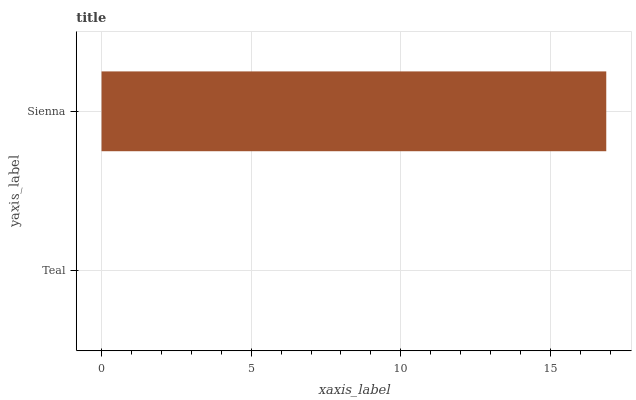Is Teal the minimum?
Answer yes or no. Yes. Is Sienna the maximum?
Answer yes or no. Yes. Is Sienna the minimum?
Answer yes or no. No. Is Sienna greater than Teal?
Answer yes or no. Yes. Is Teal less than Sienna?
Answer yes or no. Yes. Is Teal greater than Sienna?
Answer yes or no. No. Is Sienna less than Teal?
Answer yes or no. No. Is Sienna the high median?
Answer yes or no. Yes. Is Teal the low median?
Answer yes or no. Yes. Is Teal the high median?
Answer yes or no. No. Is Sienna the low median?
Answer yes or no. No. 